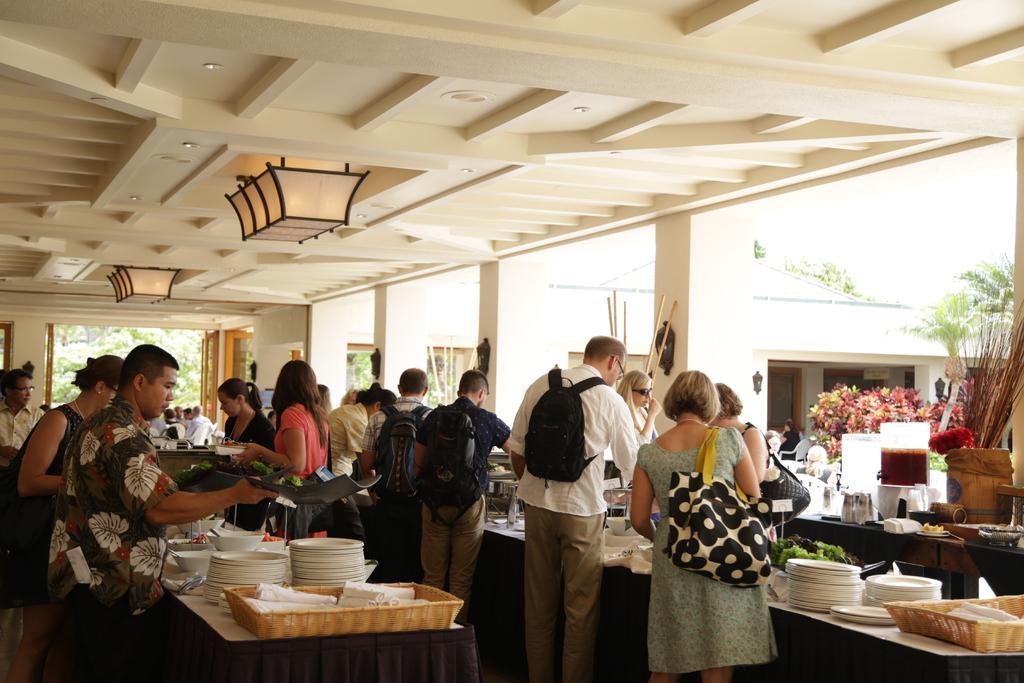Describe this image in one or two sentences. In this picture, we see group of people standing and serving food in their plates and we see few trees sound 